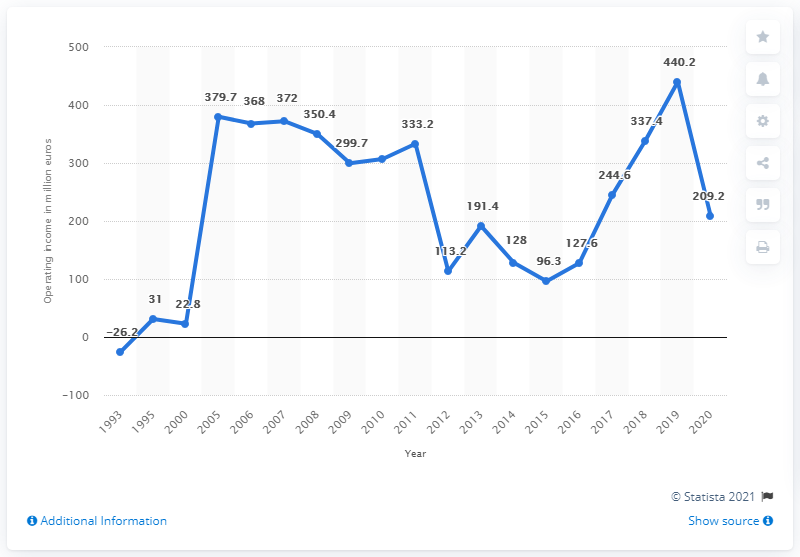What is the average operating income from 1993 to 2007? Based on the provided line graph, the average operating income from 1993 to 2007 appears to be approximately $191.22 million. This estimate considers the fluctuating operating income values over that period, which include years of high profitability as well as a notable deficit in 1993. 